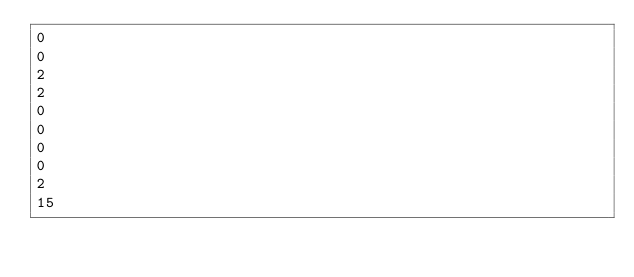Convert code to text. <code><loc_0><loc_0><loc_500><loc_500><_OCaml_>0
0
2
2
0
0
0
0
2
15
</code> 